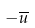Convert formula to latex. <formula><loc_0><loc_0><loc_500><loc_500>- \overline { u }</formula> 